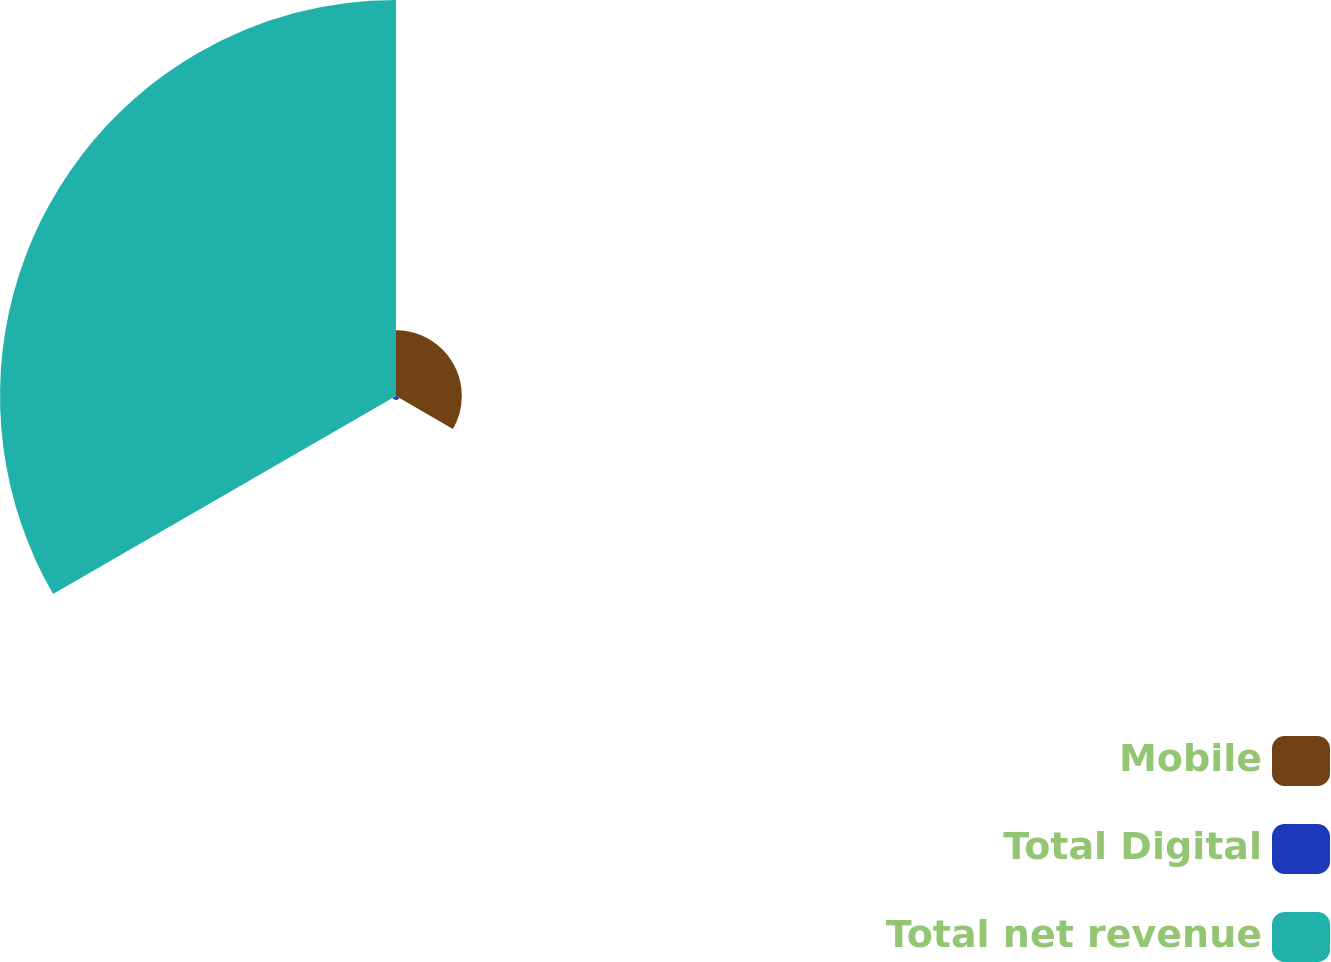<chart> <loc_0><loc_0><loc_500><loc_500><pie_chart><fcel>Mobile<fcel>Total Digital<fcel>Total net revenue<nl><fcel>14.13%<fcel>0.83%<fcel>85.04%<nl></chart> 